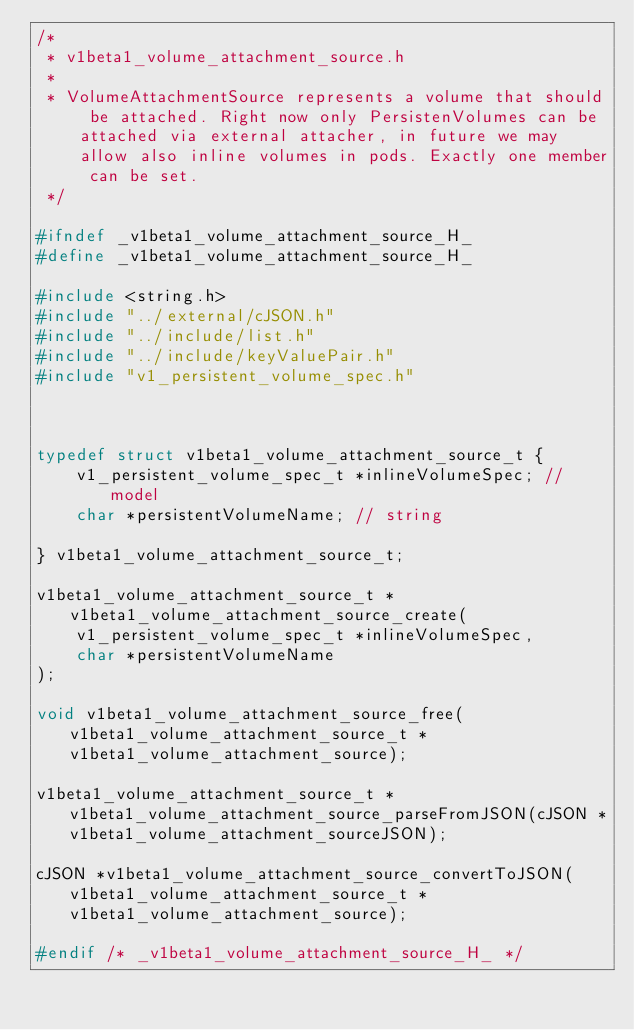Convert code to text. <code><loc_0><loc_0><loc_500><loc_500><_C_>/*
 * v1beta1_volume_attachment_source.h
 *
 * VolumeAttachmentSource represents a volume that should be attached. Right now only PersistenVolumes can be attached via external attacher, in future we may allow also inline volumes in pods. Exactly one member can be set.
 */

#ifndef _v1beta1_volume_attachment_source_H_
#define _v1beta1_volume_attachment_source_H_

#include <string.h>
#include "../external/cJSON.h"
#include "../include/list.h"
#include "../include/keyValuePair.h"
#include "v1_persistent_volume_spec.h"



typedef struct v1beta1_volume_attachment_source_t {
    v1_persistent_volume_spec_t *inlineVolumeSpec; //model
    char *persistentVolumeName; // string

} v1beta1_volume_attachment_source_t;

v1beta1_volume_attachment_source_t *v1beta1_volume_attachment_source_create(
    v1_persistent_volume_spec_t *inlineVolumeSpec,
    char *persistentVolumeName
);

void v1beta1_volume_attachment_source_free(v1beta1_volume_attachment_source_t *v1beta1_volume_attachment_source);

v1beta1_volume_attachment_source_t *v1beta1_volume_attachment_source_parseFromJSON(cJSON *v1beta1_volume_attachment_sourceJSON);

cJSON *v1beta1_volume_attachment_source_convertToJSON(v1beta1_volume_attachment_source_t *v1beta1_volume_attachment_source);

#endif /* _v1beta1_volume_attachment_source_H_ */

</code> 